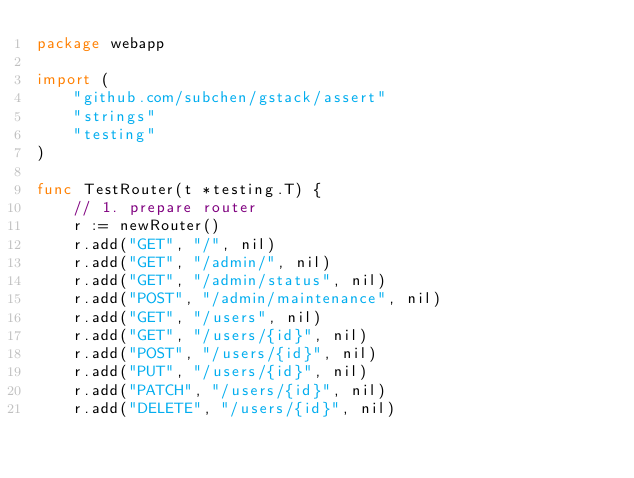<code> <loc_0><loc_0><loc_500><loc_500><_Go_>package webapp

import (
	"github.com/subchen/gstack/assert"
	"strings"
	"testing"
)

func TestRouter(t *testing.T) {
	// 1. prepare router
	r := newRouter()
	r.add("GET", "/", nil)
	r.add("GET", "/admin/", nil)
	r.add("GET", "/admin/status", nil)
	r.add("POST", "/admin/maintenance", nil)
	r.add("GET", "/users", nil)
	r.add("GET", "/users/{id}", nil)
	r.add("POST", "/users/{id}", nil)
	r.add("PUT", "/users/{id}", nil)
	r.add("PATCH", "/users/{id}", nil)
	r.add("DELETE", "/users/{id}", nil)</code> 